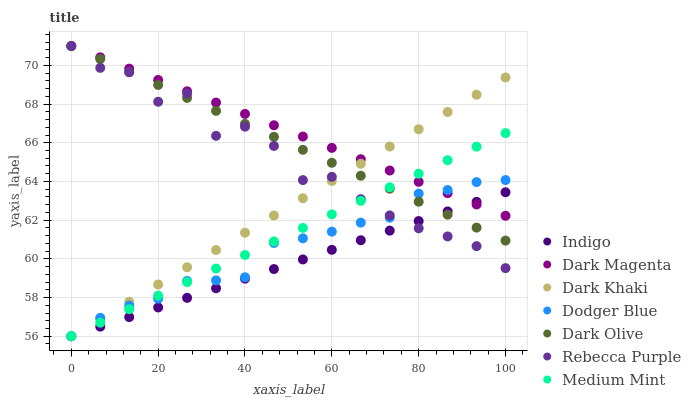Does Indigo have the minimum area under the curve?
Answer yes or no. Yes. Does Dark Magenta have the maximum area under the curve?
Answer yes or no. Yes. Does Dark Magenta have the minimum area under the curve?
Answer yes or no. No. Does Indigo have the maximum area under the curve?
Answer yes or no. No. Is Indigo the smoothest?
Answer yes or no. Yes. Is Rebecca Purple the roughest?
Answer yes or no. Yes. Is Dark Magenta the smoothest?
Answer yes or no. No. Is Dark Magenta the roughest?
Answer yes or no. No. Does Medium Mint have the lowest value?
Answer yes or no. Yes. Does Dark Magenta have the lowest value?
Answer yes or no. No. Does Rebecca Purple have the highest value?
Answer yes or no. Yes. Does Indigo have the highest value?
Answer yes or no. No. Does Dark Khaki intersect Indigo?
Answer yes or no. Yes. Is Dark Khaki less than Indigo?
Answer yes or no. No. Is Dark Khaki greater than Indigo?
Answer yes or no. No. 